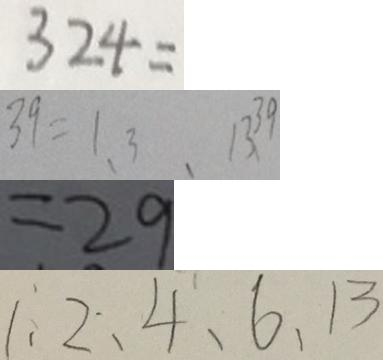<formula> <loc_0><loc_0><loc_500><loc_500>3 2 4 = 
 3 9 = 1 、 3 、 1 3 、 3 9 
 = 2 9 
 1 、 2 、 4 、 6 、 1 3</formula> 